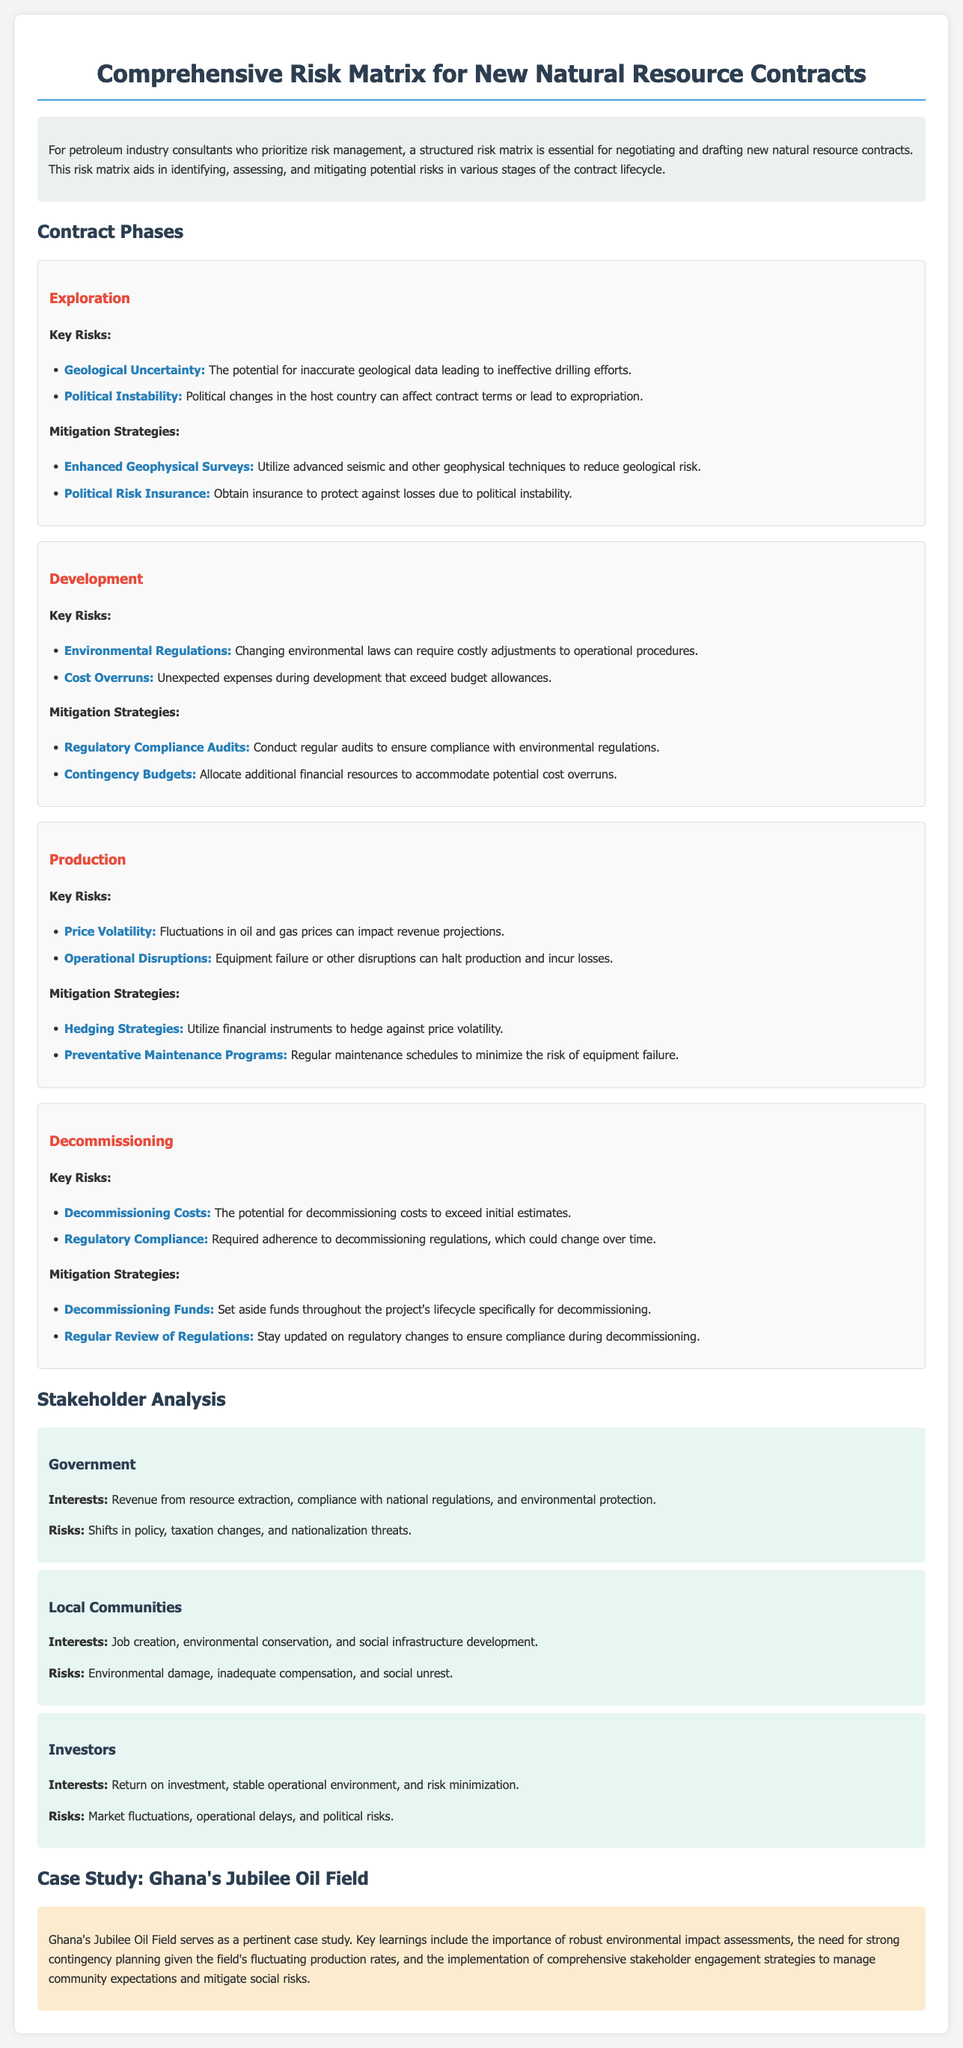What is the title of the document? The title of the document is specified in the header section, which provides an overview of the content.
Answer: Comprehensive Risk Matrix for New Natural Resource Contracts What is a key risk in the Exploration phase? The document lists specific risks associated with each phase, including key risks in the Exploration phase.
Answer: Geological Uncertainty What mitigation strategy is suggested for Cost Overruns? The document outlines strategies to mitigate risks, which include specific solutions for the Development phase.
Answer: Contingency Budgets Who are the stakeholders mentioned in the document? The document identifies various stakeholders involved in the natural resource contracts.
Answer: Government, Local Communities, Investors What are the interests of Local Communities? Each stakeholder's interests are detailed, providing insight into their concerns.
Answer: Job creation, environmental conservation, and social infrastructure development What does the case study in the document focus on? The case study provides relevant insights from a specific example within the industry.
Answer: Ghana's Jubilee Oil Field What are decommissioning costs categorized under? The document organizes risks by phases, including decommissioning costs.
Answer: Key Risks What is one of the mitigation strategies for Decommissioning? The mitigation strategies are outlined to manage the associated risks during the decommissioning phase.
Answer: Decommissioning Funds 